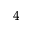<formula> <loc_0><loc_0><loc_500><loc_500>^ { 4 }</formula> 